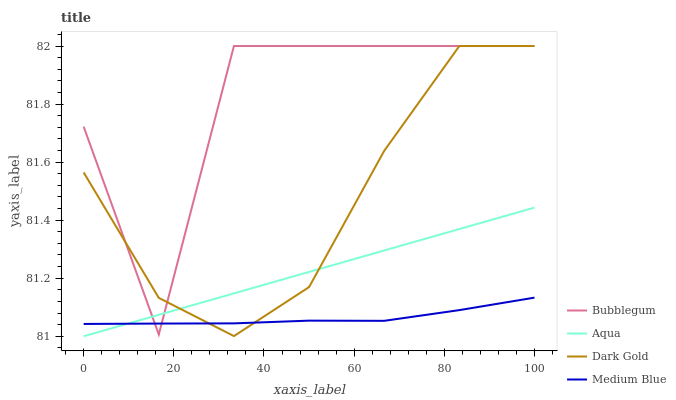Does Medium Blue have the minimum area under the curve?
Answer yes or no. Yes. Does Bubblegum have the maximum area under the curve?
Answer yes or no. Yes. Does Aqua have the minimum area under the curve?
Answer yes or no. No. Does Aqua have the maximum area under the curve?
Answer yes or no. No. Is Aqua the smoothest?
Answer yes or no. Yes. Is Bubblegum the roughest?
Answer yes or no. Yes. Is Bubblegum the smoothest?
Answer yes or no. No. Is Aqua the roughest?
Answer yes or no. No. Does Aqua have the lowest value?
Answer yes or no. Yes. Does Bubblegum have the lowest value?
Answer yes or no. No. Does Dark Gold have the highest value?
Answer yes or no. Yes. Does Aqua have the highest value?
Answer yes or no. No. Does Bubblegum intersect Aqua?
Answer yes or no. Yes. Is Bubblegum less than Aqua?
Answer yes or no. No. Is Bubblegum greater than Aqua?
Answer yes or no. No. 